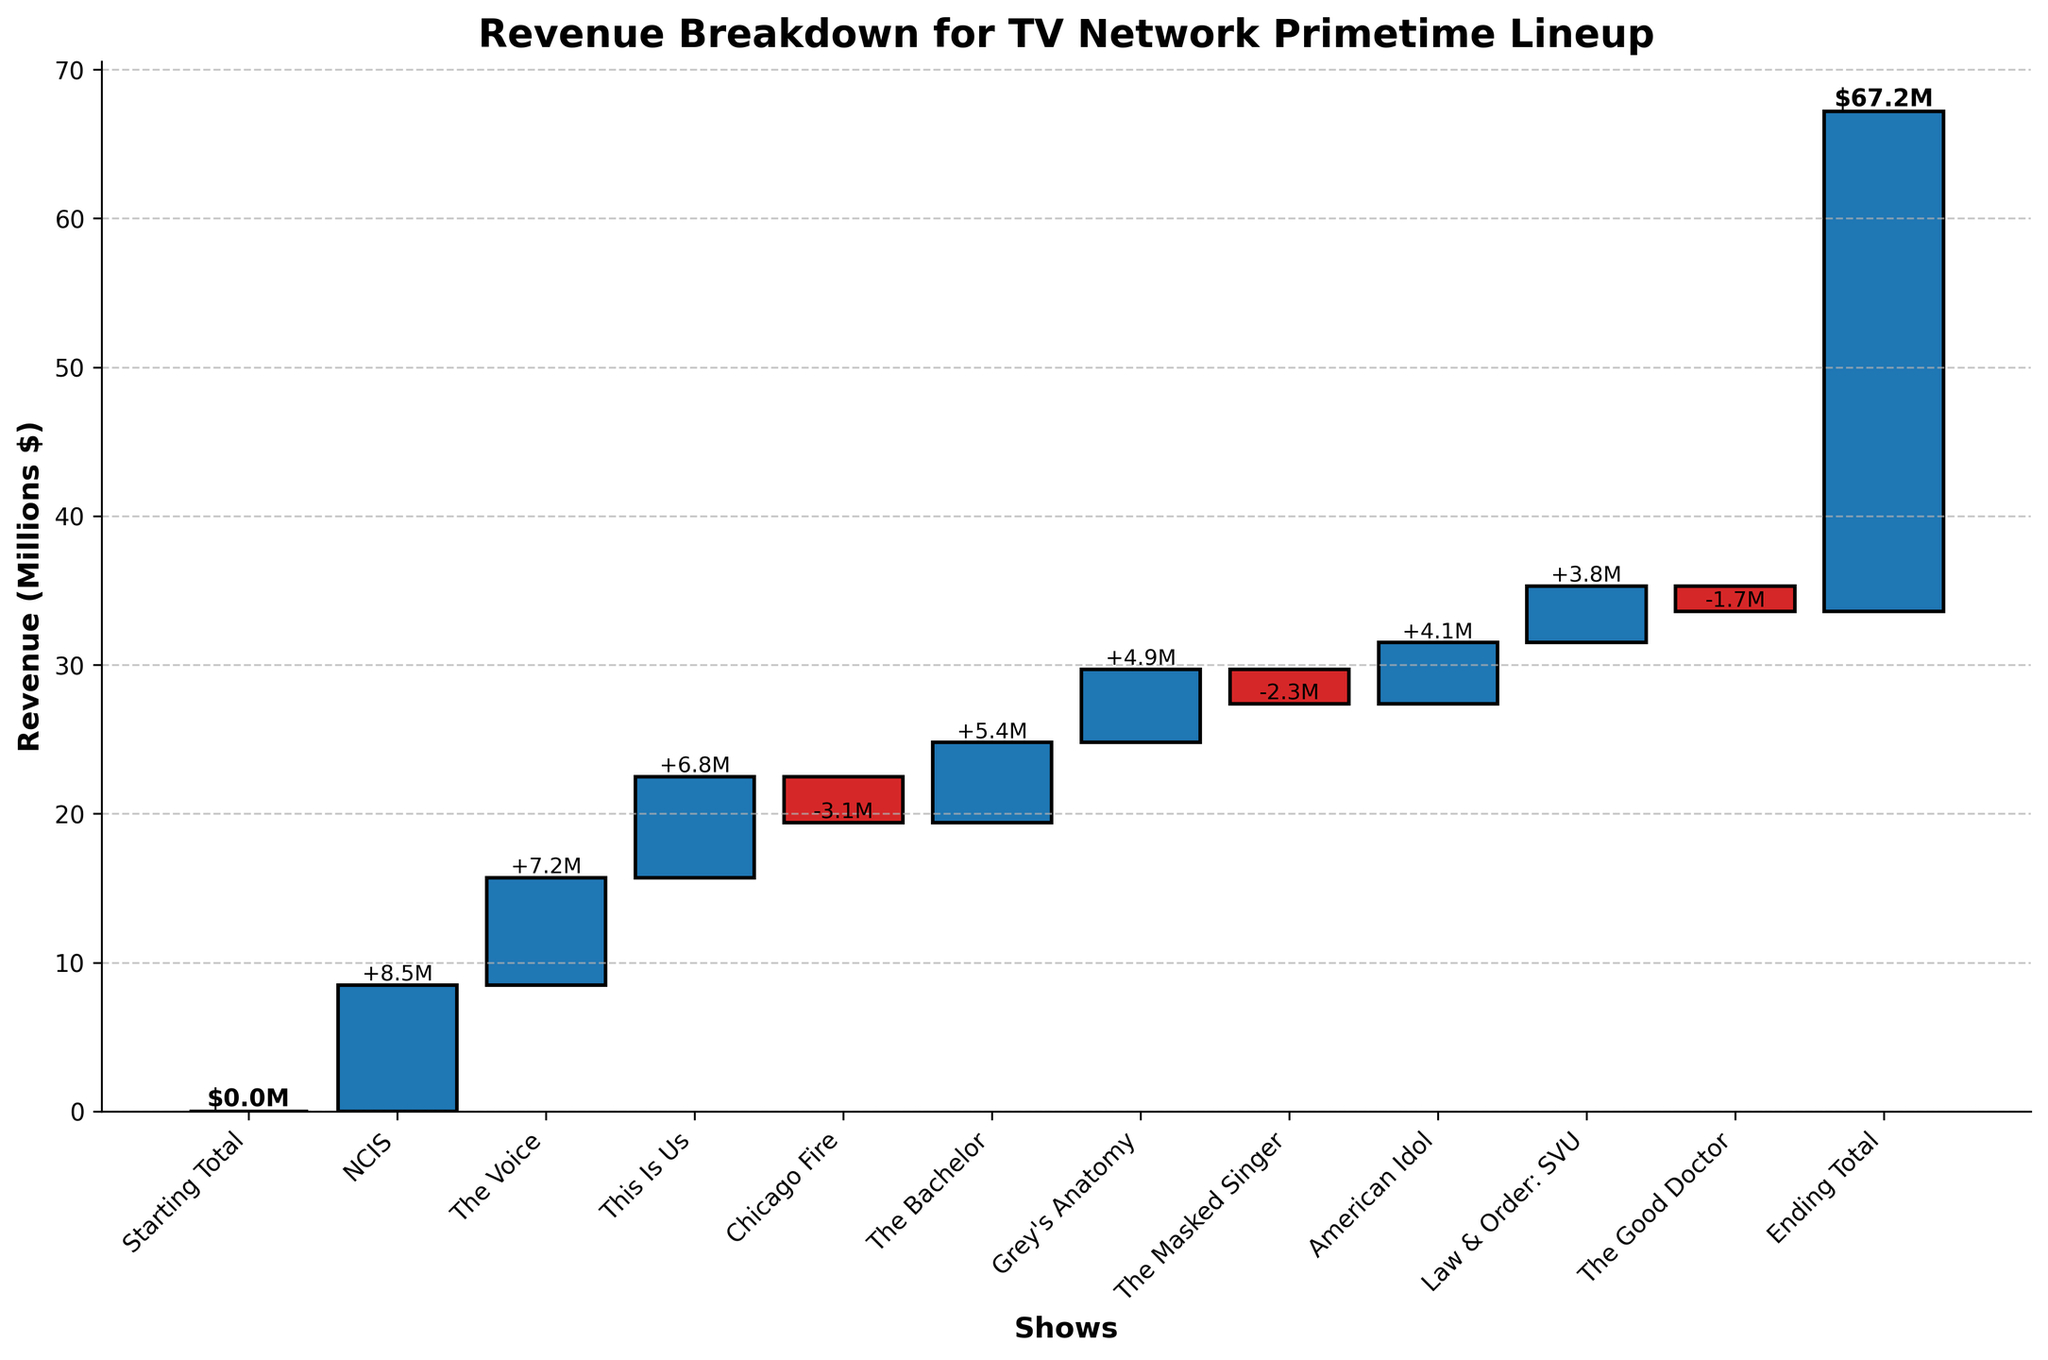What's the title of the chart? The title of the chart is usually displayed at the top in a larger and bold font, which helps the viewer to understand the subject of the chart. In this chart, the title is clearly written.
Answer: Revenue Breakdown for TV Network Primetime Lineup What is the revenue generated by the show "NCIS"? To find the revenue generated by "NCIS", locate its bar on the x-axis and read the value displayed either on the bar itself or relative to the y-axis.
Answer: $8.5M Which show has the highest positive impact on revenue? To find the show with the highest positive impact, compare the heights of the bars that have positive values. The highest bar represents the show with the highest revenue increase.
Answer: NCIS What is the total ending revenue? Look for the last bar labeled "Ending Total". The value displayed on this bar represents the total ending revenue.
Answer: $33.6M What is the decrease in revenue due to "Chicago Fire"? Identify the bar corresponding to "Chicago Fire" and note the value. Since it's a decrease, it should be represented by a negative number.
Answer: -$3.1M Which shows resulted in a decrease in revenue? Look for bars that are going downwards (negative values) in the chart. The labels on these bars indicate the shows that caused a revenue decrease.
Answer: Chicago Fire, The Masked Singer, The Good Doctor What is the cumulative revenue after airing "The Voice"? To find the cumulative revenue after "The Voice", you need to account for the starting total and the revenues from shows up to and including "The Voice". Adding the values from "Starting Total" to "The Voice" will give the cumulative revenue.
Answer: $15.7M How does the revenue contribution of "The Bachelor" compare to "Grey's Anatomy"? Compare the height of the bars corresponding to "The Bachelor" and "Grey's Anatomy". The bar with a higher value indicates a larger contribution.
Answer: "The Bachelor" has a higher contribution What's the net change in revenue caused by the shows "The Masked Singer" and "American Idol"? Find the revenue values for both shows, which are -$2.3M for "The Masked Singer" and +$4.1M for "American Idol". Add these values together to get the net change.
Answer: $1.8M What is the average revenue generated by the shows excluding the decreases? To find the average revenue from shows with positive contributions, sum these positive values and divide by the number of shows.
Answer: $6.1M 